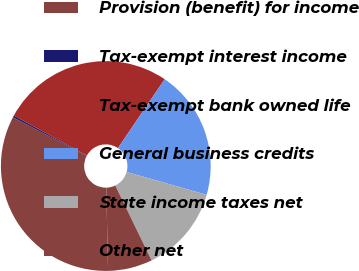Convert chart to OTSL. <chart><loc_0><loc_0><loc_500><loc_500><pie_chart><fcel>Provision (benefit) for income<fcel>Tax-exempt interest income<fcel>Tax-exempt bank owned life<fcel>General business credits<fcel>State income taxes net<fcel>Other net<nl><fcel>33.05%<fcel>0.28%<fcel>26.5%<fcel>19.94%<fcel>13.39%<fcel>6.84%<nl></chart> 